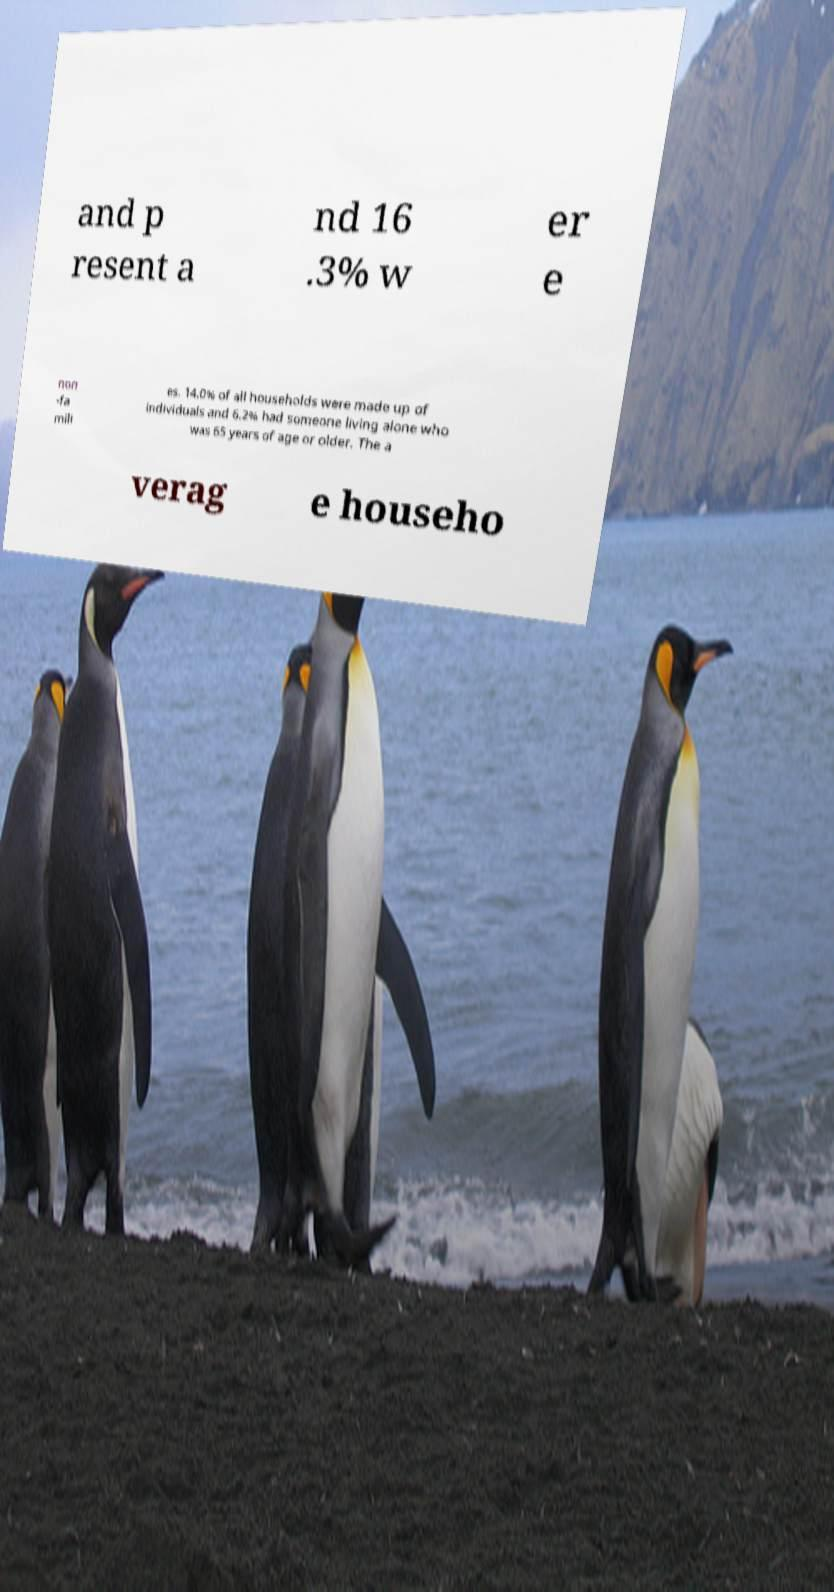I need the written content from this picture converted into text. Can you do that? and p resent a nd 16 .3% w er e non -fa mili es. 14.0% of all households were made up of individuals and 6.2% had someone living alone who was 65 years of age or older. The a verag e househo 